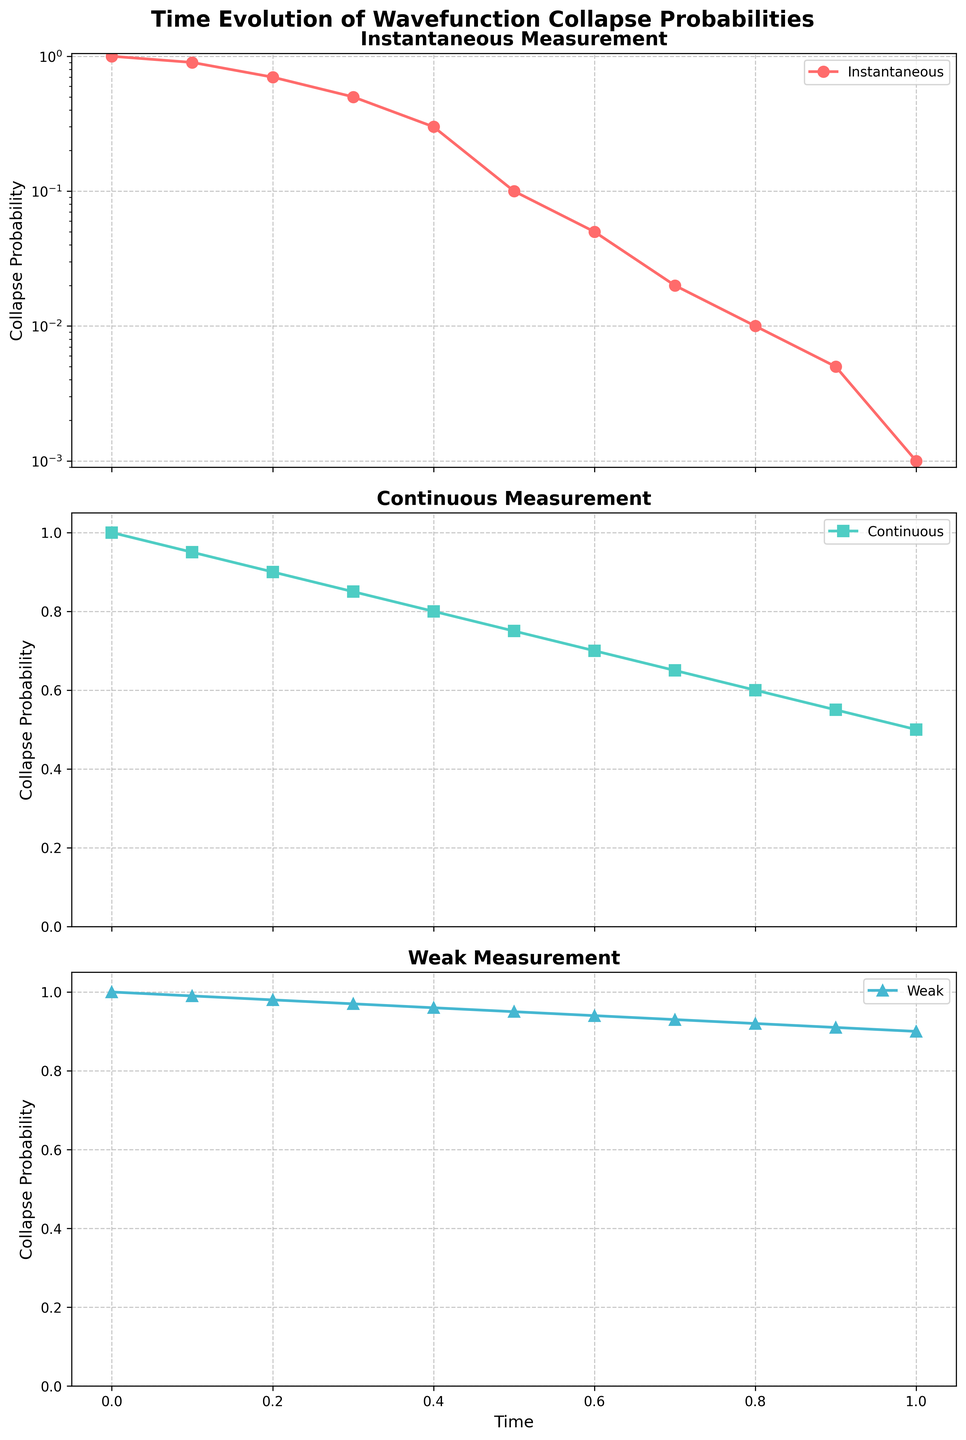What is the general trend observed in the probability of wavefunction collapse over time for the 'Instantaneous' measurement? The 'Instantaneous' measurement shows a rapid decrease in the probability of wavefunction collapse over time, transitioning from 1.0 at time 0 to nearly 0.001 at time 1. This rapid decline is represented on a logarithmic scale.
Answer: Rapid decrease Which measurement type maintains the highest wavefunction collapse probability at time = 1.0? The 'Weak' measurement maintains the highest probability, which is 0.9 at time 1.0. This can be seen on the third subplot where the wavefunction collapse probability is plotted for the 'Weak' measurement.
Answer: Weak At what time do the probabilities of wavefunction collapse for 'Instantaneous' and 'Continuous' measurements become equal? By inspecting the two curves for 'Instantaneous' and 'Continuous' measurements, they do not actually intersect at any point within the time range from 0 to 1.0. Therefore, they do not have equal probabilities at any time value.
Answer: Never For the 'Continuous' measurement, calculate the difference in wavefunction collapse probabilities between time = 0.5 and time = 1.0. At time = 0.5, the probability is 0.75, and at time = 1.0, it is 0.5. The difference is 0.75 - 0.5.
Answer: 0.25 Which measurement type has the steepest decline in wavefunction collapse probability? The steepest decline is observed in the 'Instantaneous' measurement, which decreases from 1.0 to 0.001 over the time span. This is visualized with a logarithmic scale, indicating a comparatively rapid drop.
Answer: Instantaneous Compare the evolution of wavefunction collapse probabilities for 'Instantaneous' and 'Weak' measurements at time = 0.5. At time = 0.5, the 'Instantaneous' probability is about 0.1, while the 'Weak' probability is 0.95. Thus, the 'Weak' measurement maintains a substantially higher probability at this time point.
Answer: Weak, higher What color represents the 'Continuous' measurement and where in the figure can this be identified? The 'Continuous' measurement is represented with a green color. This can be seen in the second subplot, where 'Continuous' is labeled in the legend and the data points connected with a green line and squares.
Answer: Green For which measurement type is the y-axis scaled logarithmically, and why might this be the case? The 'Instantaneous' measurement uses a logarithmic scale on the y-axis. This is likely because the data spans several orders of magnitude, decreasing rapidly from 1.0 to 0.001, which a logarithmic scale accommodates well.
Answer: Instantaneous What is the visual representation style (marker and line) for the 'Weak' measurement, and how does it differ from the other measurements? The 'Weak' measurement uses triangle markers and a blue line. This differs from 'Instantaneous' which uses circular markers and a red line, and 'Continuous' which uses square markers and a green line.
Answer: Triangle, blue 